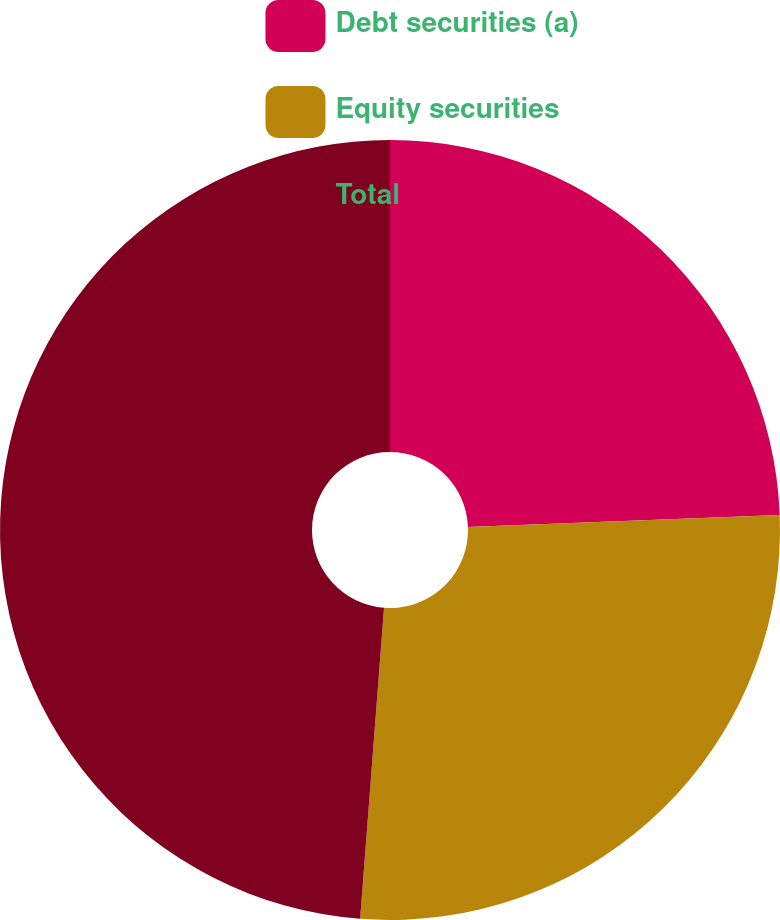Convert chart. <chart><loc_0><loc_0><loc_500><loc_500><pie_chart><fcel>Debt securities (a)<fcel>Equity securities<fcel>Total<nl><fcel>24.39%<fcel>26.83%<fcel>48.78%<nl></chart> 